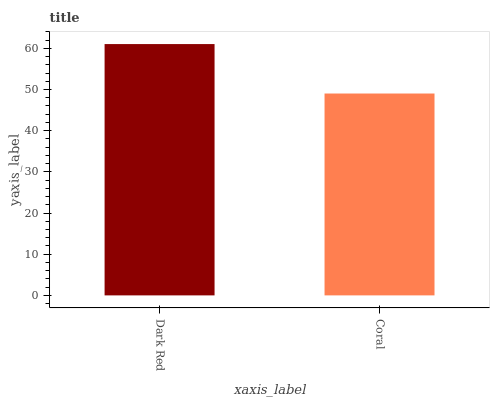Is Coral the minimum?
Answer yes or no. Yes. Is Dark Red the maximum?
Answer yes or no. Yes. Is Coral the maximum?
Answer yes or no. No. Is Dark Red greater than Coral?
Answer yes or no. Yes. Is Coral less than Dark Red?
Answer yes or no. Yes. Is Coral greater than Dark Red?
Answer yes or no. No. Is Dark Red less than Coral?
Answer yes or no. No. Is Dark Red the high median?
Answer yes or no. Yes. Is Coral the low median?
Answer yes or no. Yes. Is Coral the high median?
Answer yes or no. No. Is Dark Red the low median?
Answer yes or no. No. 